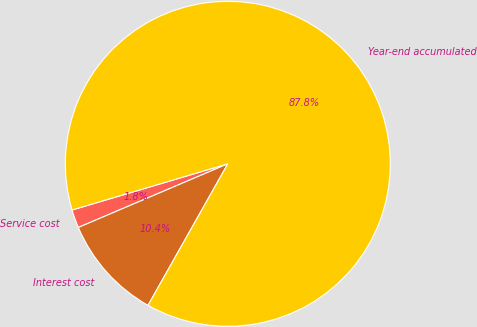Convert chart. <chart><loc_0><loc_0><loc_500><loc_500><pie_chart><fcel>Service cost<fcel>Interest cost<fcel>Year-end accumulated<nl><fcel>1.82%<fcel>10.42%<fcel>87.76%<nl></chart> 